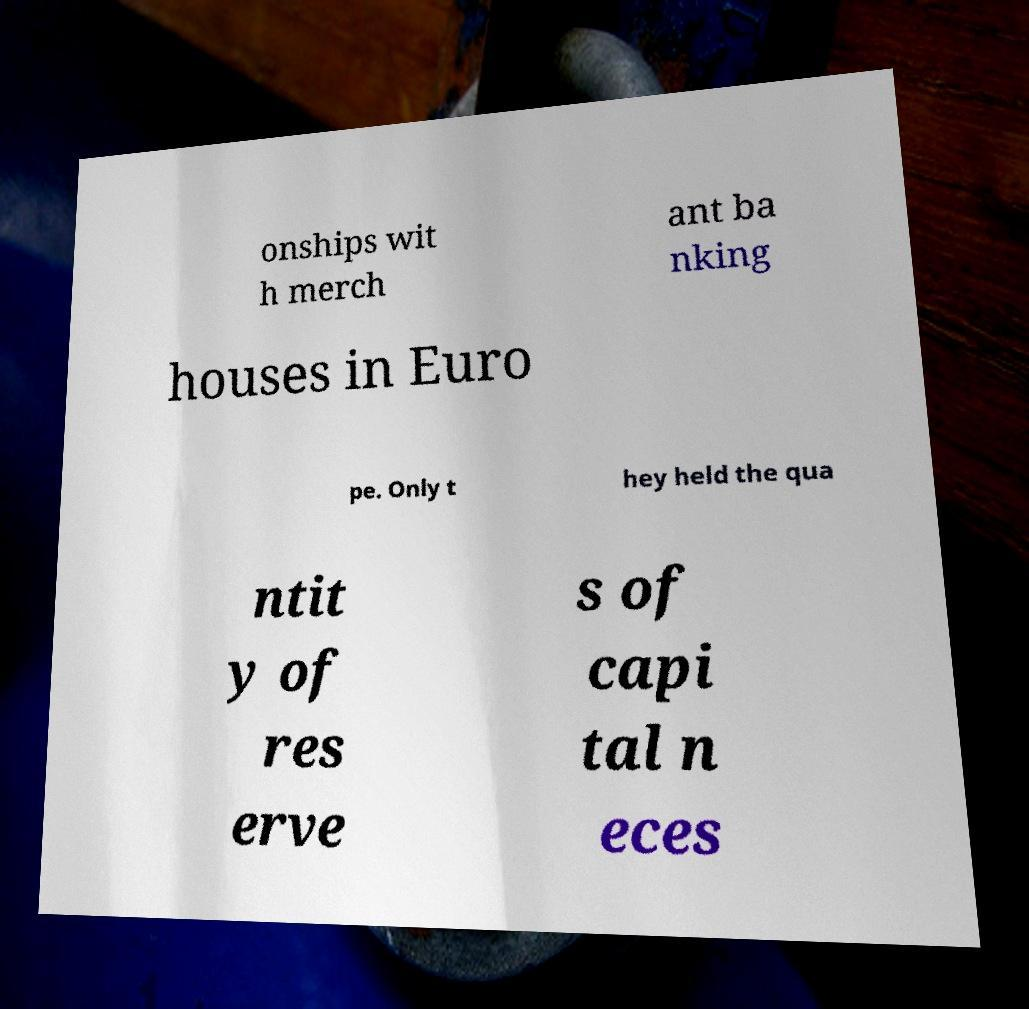There's text embedded in this image that I need extracted. Can you transcribe it verbatim? onships wit h merch ant ba nking houses in Euro pe. Only t hey held the qua ntit y of res erve s of capi tal n eces 